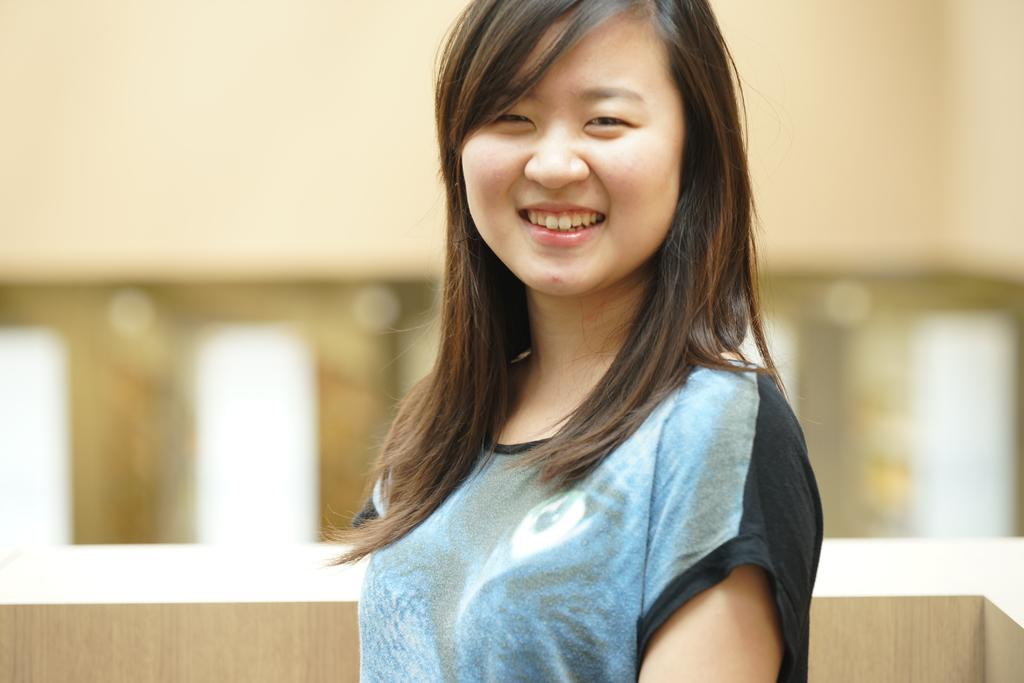Who is present in the image? There is a woman in the image. What is the woman's facial expression? The woman is smiling. Can you describe the background of the image? The background of the image is blurred. How many chairs can be seen in the image? There are no chairs visible in the image. Is there a girl in the image? The image only features a woman, not a girl. Can you see a judge in the image? There is no judge present in the image. 